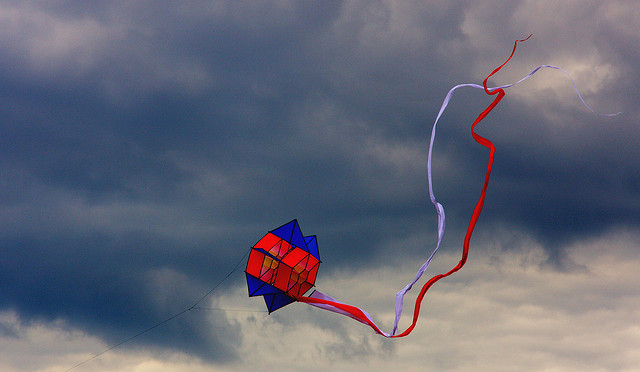Imagine you are a kite scientist. How would you explain the physics behind the kite's flight? As a kite scientist, I'd explain that the flight of the kite relies on a balance of forces. Lift is generated when the wind flows over and under the kite at different speeds, creating a pressure difference. The kite is designed to harness this lift by having an aerodynamic shape that promotes smooth airflow. Tension in the string anchors it against the upward lift, while gravity pulls down. Properly angling the kite relative to the wind ensures it climbs into the sky. The tails add stability by preventing it from spinning erratically, ensuring it maintains a steady flight pattern even as wind conditions vary. Describe a typical day at a kite festival where this kite could be flown. A typical day at a kite festival is brimming with excitement and color. Enthusiasts gather early, filling the sky with kites of all shapes and sizes. Children run joyfully amidst adults, guiding their kites higher with each gust of wind. Booths line the festival grounds, offering refreshments and kite-making workshops. The air is alive with the joyful chatter of families and the rhythmic flapping of kite fabric. Competitions might be held, with participants showcasing innovative designs and flying techniques. As evening approaches, the sky glows in the soft light of the setting sun, and the scene transforms into a picturesque tableau of airborne art. Invent a fantastical story where this kite plays a key role. Once in a realm where the sky was an artist's canvas, there existed a kite made not of fabric and string, but of dreams and stardust. Legends spoke of a day when the Dream Kite would choose a worthy heart - someone brave and pure - to embark on a quest to restore the fading colors of the sky. One stormy evening, atop a hill, a young dreamer named Aria released the Dream Kite into the turbulent winds. As it soared higher, the sky began to shimmer with forgotten hues, and Aria found herself lifted into a world where the clouds were tales and the stars whispered secrets. Guided by the kite, Aria navigated the realm of forgotten dreams, weaving colors back into the fabric of dawn and dusk. Her journey was filled with enchanted creatures and trials of courage, each step restoring a piece of the ethereal canvas until the sky was once again a glorious tapestry of wonder. 